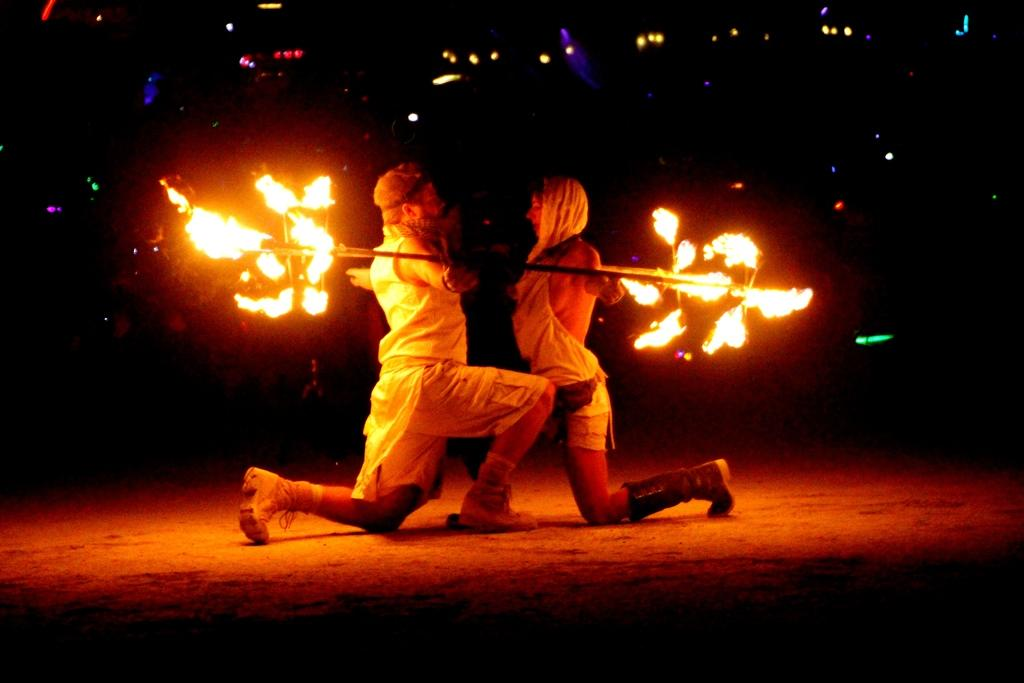Who are the people in the foreground of the image? There is a man and a woman in the foreground of the image. What are the man and woman holding in their hands? They are holding a stick with fire in their hands. What is the lighting condition in the background of the image? The background of the image is dark. What type of lights can be seen in the background of the image? There are color lights in the background of the image. What type of calculator is the man using in the image? There is no calculator present in the image; the man and woman are holding a stick with fire. How many legs does the power source have in the image? There is no power source present in the image, as the man and woman are holding a stick with fire. 